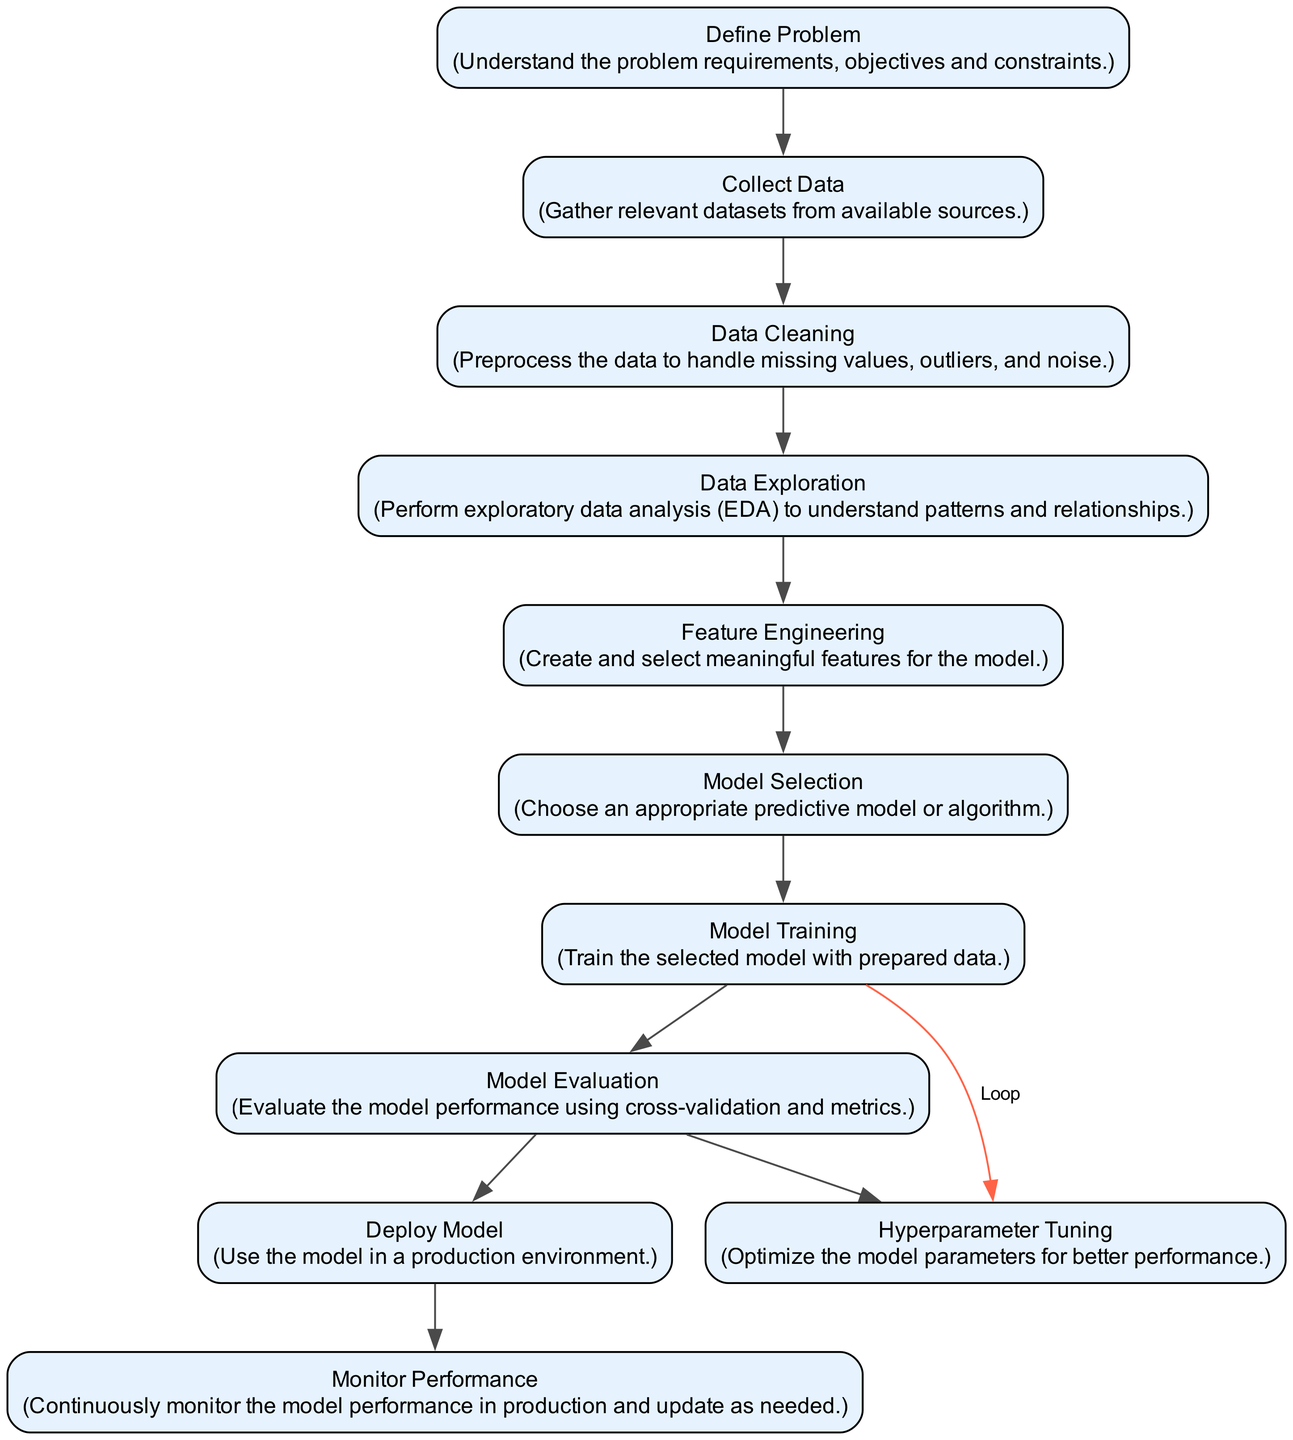What is the first activity in the workflow? The diagram indicates that the first activity in the workflow is "Define Problem," which is clearly labeled at the top of the flowchart.
Answer: Define Problem How many activities are there in total? By counting each unique activity node in the diagram, it can be determined that there are eleven activities listed, each representing a step in the model-building process.
Answer: Eleven What follows Data Cleaning in the workflow? The diagram shows an edge leading from "Data Cleaning" to "Data Exploration," indicating that Data Exploration is the next activity after Data Cleaning.
Answer: Data Exploration Which two activities precede Hyperparameter Tuning? The diagram indicates that both "Model Evaluation" and "Model Training" occur before Hyperparameter Tuning. First, after Model Evaluation, if parameters need adjustment, it returns to Model Training before refining in Hyperparameter Tuning.
Answer: Model Evaluation, Model Training What is the final activity of the workflow? The edge stemming from "Deploy Model" leads to "Monitor Performance," indicating that this is the last step in the workflow process for building and deploying a predictive model.
Answer: Monitor Performance Which activities are connected by a loop in the workflow? The relationship labeled as "Loop" from "Hyperparameter Tuning" back to "Model Training" indicates these two activities are interconnected in a repeating manner. The loop signifies that after tuning hyperparameters, the model may require retraining.
Answer: Hyperparameter Tuning, Model Training What is the relationship type between Model Evaluation and Deploy Model? The arrow between "Model Evaluation" and "Deploy Model" is labeled as "Sequence," meaning that Deploy Model directly follows the completion of Model Evaluation as part of the workflow's progression.
Answer: Sequence How many loops are present in the diagram? The diagram shows a single loop that connects Hyperparameter Tuning back to Model Training, indicating that only one circular flow exists in the workflow structure.
Answer: One 